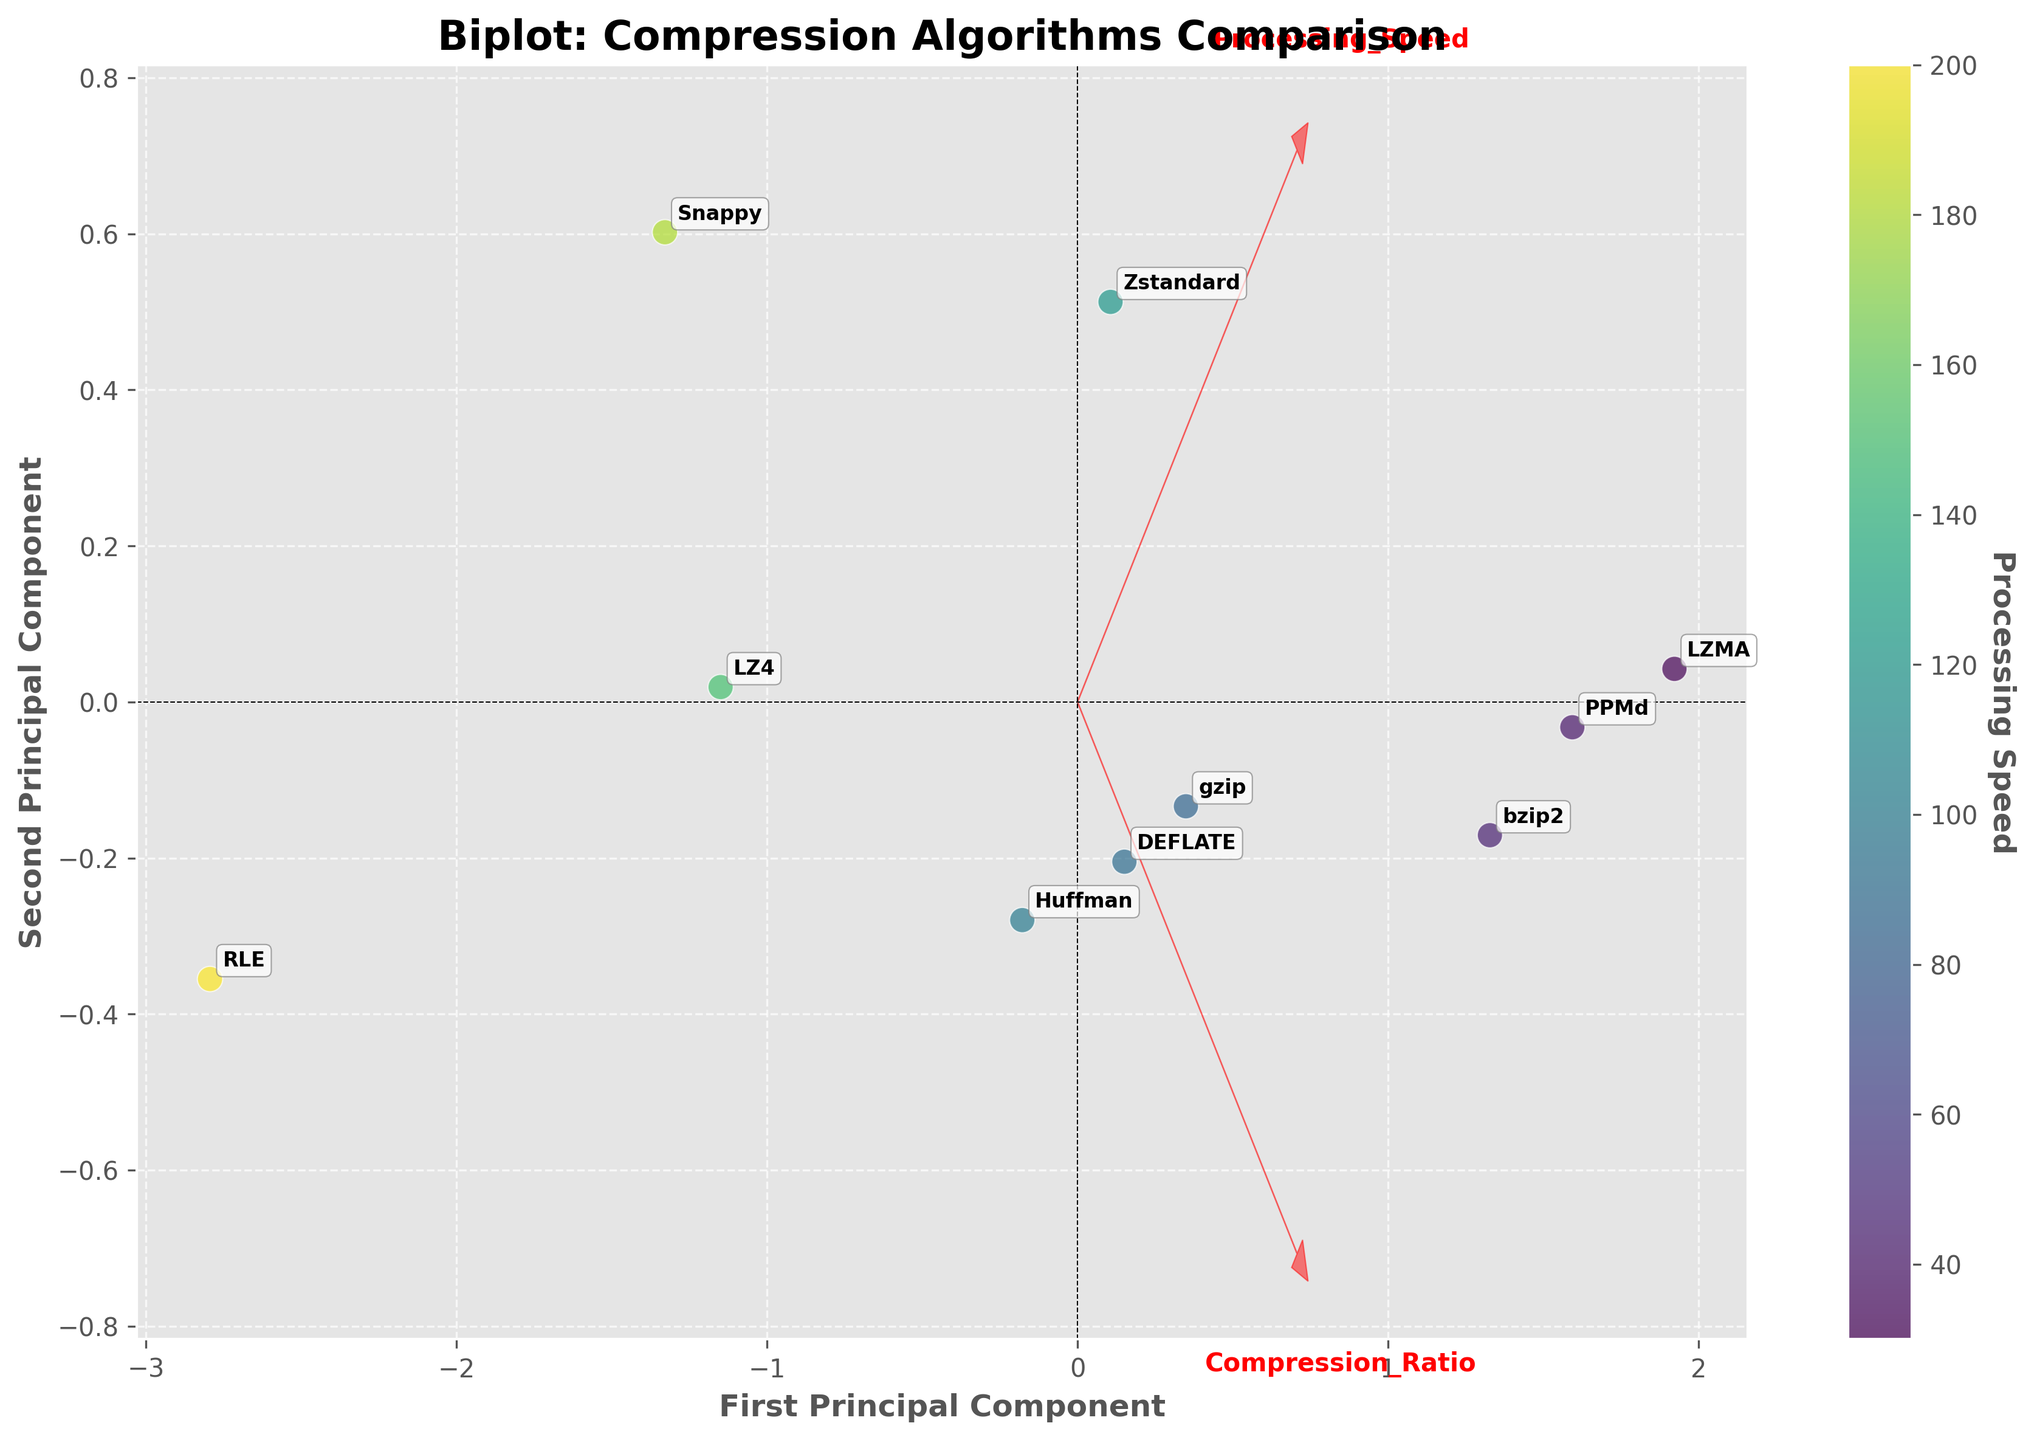What's the title of the plot? The title of the plot is shown at the top of the figure, which is often used to describe the main topic or focus of the plot.
Answer: Biplot: Compression Algorithms Comparison How many data points are included in the plot? Each data point represents an algorithm, and they are scattered across the plot. Count the total number of these data points, including the annotated labels.
Answer: 10 Which algorithm has the highest processing speed? Identify the data point that has the most intense color as it represents the highest value on the color scale, and refer to the annotated label for the algorithm’s name.
Answer: RLE Which algorithm has the lowest compression ratio? Compression ratio is one of the features plotted, represented as a vector. Locate the data point nearest to the vector tip representing the lowest compression ratio and check its label.
Answer: RLE How do the compression ratio and processing speed vectors appear in the plot? Look at the feature vectors (indicated by arrows) in the plot and describe their orientation and relationship to each other. For example, mention their angles and lengths.
Answer: The compression ratio and processing speed vectors are orthogonal, indicating no correlation Which algorithm is closest to the first principal component axis? The first principal component axis is usually the horizontal axis. Locate the data point that is nearest to this axis along the horizontal direction.
Answer: gzip What can be said about the relationship between ‘bzip2’ and ‘Zstandard’? Compare the two algorithms in terms of their positions in the plot relative to the compression ratio and processing speed vectors, noting proximity and directionality in respect to these features.
Answer: bzip2 and Zstandard have similar processing speeds but different compression ratios Which principal component explains most of the variance in the data? Look for the principal component that aligns most closely with the direction of the data points, often indicated by the range covered along that axis.
Answer: First principal component What color represents the lowest processing speed, and which algorithm does it correspond to? Find the point with the least intense color on the color scale and refer to the annotated label for the algorithm’s name.
Answer: LZMA Is there an algorithm with both high compression ratio and high processing speed? Analyze the positions of the data points in relation to both the compression ratio and processing speed vectors, identifying if any point is near the extremes of both vectors.
Answer: No 